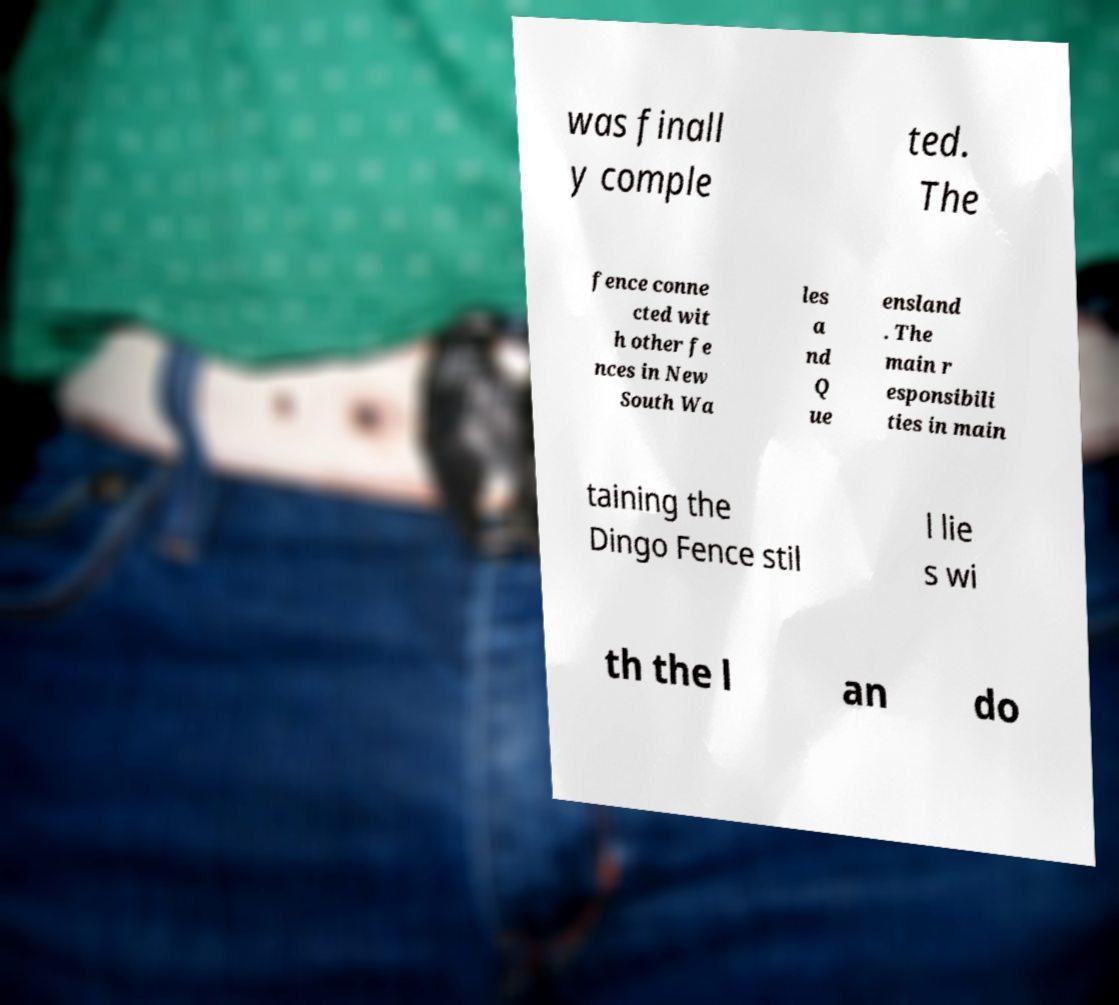There's text embedded in this image that I need extracted. Can you transcribe it verbatim? was finall y comple ted. The fence conne cted wit h other fe nces in New South Wa les a nd Q ue ensland . The main r esponsibili ties in main taining the Dingo Fence stil l lie s wi th the l an do 